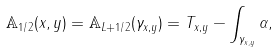Convert formula to latex. <formula><loc_0><loc_0><loc_500><loc_500>\mathbb { A } _ { 1 / 2 } ( x , y ) = \mathbb { A } _ { L + 1 / 2 } ( \gamma _ { x , y } ) = T _ { x , y } - \int _ { \gamma _ { x , y } } \alpha ,</formula> 